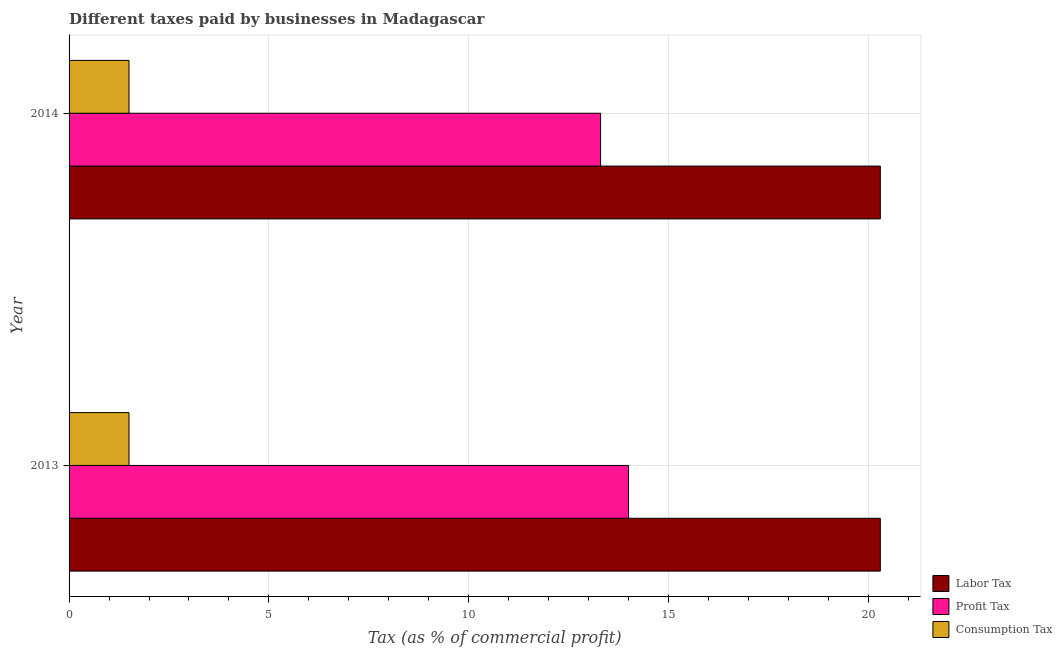How many groups of bars are there?
Your answer should be compact. 2. Are the number of bars per tick equal to the number of legend labels?
Ensure brevity in your answer.  Yes. What is the label of the 2nd group of bars from the top?
Keep it short and to the point. 2013. In how many cases, is the number of bars for a given year not equal to the number of legend labels?
Keep it short and to the point. 0. What is the percentage of labor tax in 2013?
Provide a succinct answer. 20.3. Across all years, what is the maximum percentage of labor tax?
Your answer should be compact. 20.3. Across all years, what is the minimum percentage of profit tax?
Your answer should be compact. 13.3. In which year was the percentage of profit tax maximum?
Keep it short and to the point. 2013. In which year was the percentage of consumption tax minimum?
Offer a very short reply. 2013. What is the difference between the percentage of profit tax in 2013 and that in 2014?
Your answer should be very brief. 0.7. What is the average percentage of labor tax per year?
Provide a succinct answer. 20.3. In the year 2014, what is the difference between the percentage of consumption tax and percentage of labor tax?
Your answer should be very brief. -18.8. In how many years, is the percentage of profit tax greater than 16 %?
Your answer should be very brief. 0. What is the ratio of the percentage of profit tax in 2013 to that in 2014?
Provide a short and direct response. 1.05. Is the percentage of profit tax in 2013 less than that in 2014?
Give a very brief answer. No. Is the difference between the percentage of labor tax in 2013 and 2014 greater than the difference between the percentage of profit tax in 2013 and 2014?
Offer a very short reply. No. What does the 2nd bar from the top in 2014 represents?
Your answer should be very brief. Profit Tax. What does the 1st bar from the bottom in 2014 represents?
Make the answer very short. Labor Tax. How many years are there in the graph?
Give a very brief answer. 2. Does the graph contain grids?
Your response must be concise. Yes. Where does the legend appear in the graph?
Offer a very short reply. Bottom right. How many legend labels are there?
Offer a very short reply. 3. What is the title of the graph?
Offer a terse response. Different taxes paid by businesses in Madagascar. What is the label or title of the X-axis?
Make the answer very short. Tax (as % of commercial profit). What is the label or title of the Y-axis?
Your answer should be compact. Year. What is the Tax (as % of commercial profit) in Labor Tax in 2013?
Offer a terse response. 20.3. What is the Tax (as % of commercial profit) of Labor Tax in 2014?
Offer a very short reply. 20.3. What is the Tax (as % of commercial profit) of Profit Tax in 2014?
Provide a short and direct response. 13.3. Across all years, what is the maximum Tax (as % of commercial profit) in Labor Tax?
Your answer should be compact. 20.3. Across all years, what is the maximum Tax (as % of commercial profit) in Profit Tax?
Offer a terse response. 14. Across all years, what is the maximum Tax (as % of commercial profit) in Consumption Tax?
Make the answer very short. 1.5. Across all years, what is the minimum Tax (as % of commercial profit) in Labor Tax?
Provide a succinct answer. 20.3. Across all years, what is the minimum Tax (as % of commercial profit) in Profit Tax?
Your answer should be compact. 13.3. What is the total Tax (as % of commercial profit) of Labor Tax in the graph?
Offer a terse response. 40.6. What is the total Tax (as % of commercial profit) of Profit Tax in the graph?
Your answer should be very brief. 27.3. What is the total Tax (as % of commercial profit) of Consumption Tax in the graph?
Your response must be concise. 3. What is the difference between the Tax (as % of commercial profit) of Labor Tax in 2013 and that in 2014?
Give a very brief answer. 0. What is the difference between the Tax (as % of commercial profit) in Profit Tax in 2013 and that in 2014?
Your answer should be compact. 0.7. What is the difference between the Tax (as % of commercial profit) in Consumption Tax in 2013 and that in 2014?
Your answer should be very brief. 0. What is the difference between the Tax (as % of commercial profit) in Labor Tax in 2013 and the Tax (as % of commercial profit) in Consumption Tax in 2014?
Keep it short and to the point. 18.8. What is the difference between the Tax (as % of commercial profit) of Profit Tax in 2013 and the Tax (as % of commercial profit) of Consumption Tax in 2014?
Offer a terse response. 12.5. What is the average Tax (as % of commercial profit) of Labor Tax per year?
Your answer should be compact. 20.3. What is the average Tax (as % of commercial profit) of Profit Tax per year?
Offer a terse response. 13.65. In the year 2013, what is the difference between the Tax (as % of commercial profit) in Profit Tax and Tax (as % of commercial profit) in Consumption Tax?
Make the answer very short. 12.5. What is the ratio of the Tax (as % of commercial profit) of Profit Tax in 2013 to that in 2014?
Your answer should be very brief. 1.05. What is the ratio of the Tax (as % of commercial profit) in Consumption Tax in 2013 to that in 2014?
Your answer should be very brief. 1. What is the difference between the highest and the second highest Tax (as % of commercial profit) of Labor Tax?
Offer a very short reply. 0. What is the difference between the highest and the second highest Tax (as % of commercial profit) of Profit Tax?
Provide a succinct answer. 0.7. What is the difference between the highest and the second highest Tax (as % of commercial profit) of Consumption Tax?
Your answer should be compact. 0. What is the difference between the highest and the lowest Tax (as % of commercial profit) of Labor Tax?
Offer a terse response. 0. What is the difference between the highest and the lowest Tax (as % of commercial profit) in Consumption Tax?
Offer a very short reply. 0. 